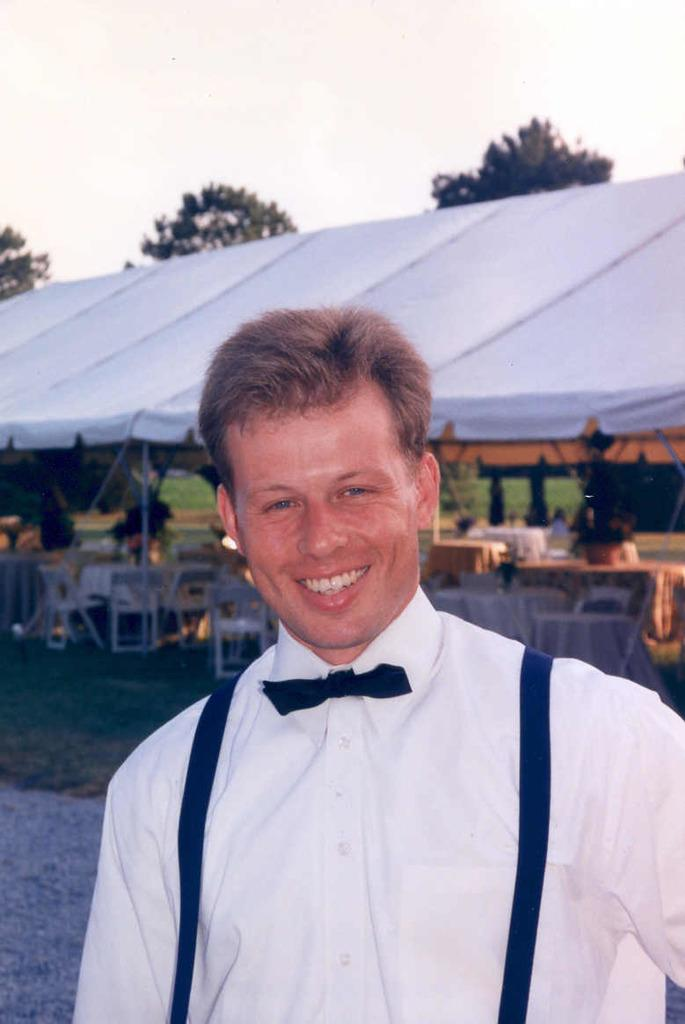What is the main subject of the image? There is a person in the image. Can you describe the person's clothing? The person is wearing a white shirt. What is the person's facial expression? The person is smiling. What structure is visible in the image? There is a tent visible in the image. What can be seen in the sky? The sky is visible in the image. What type of furniture is present under the tent? There are tables and chairs under the tent. How many other persons are present in the image? There are other persons present in the image. What type of tin can be seen in the image? There is no tin present in the image. Are there any ghosts visible in the image? There are no ghosts present in the image. 